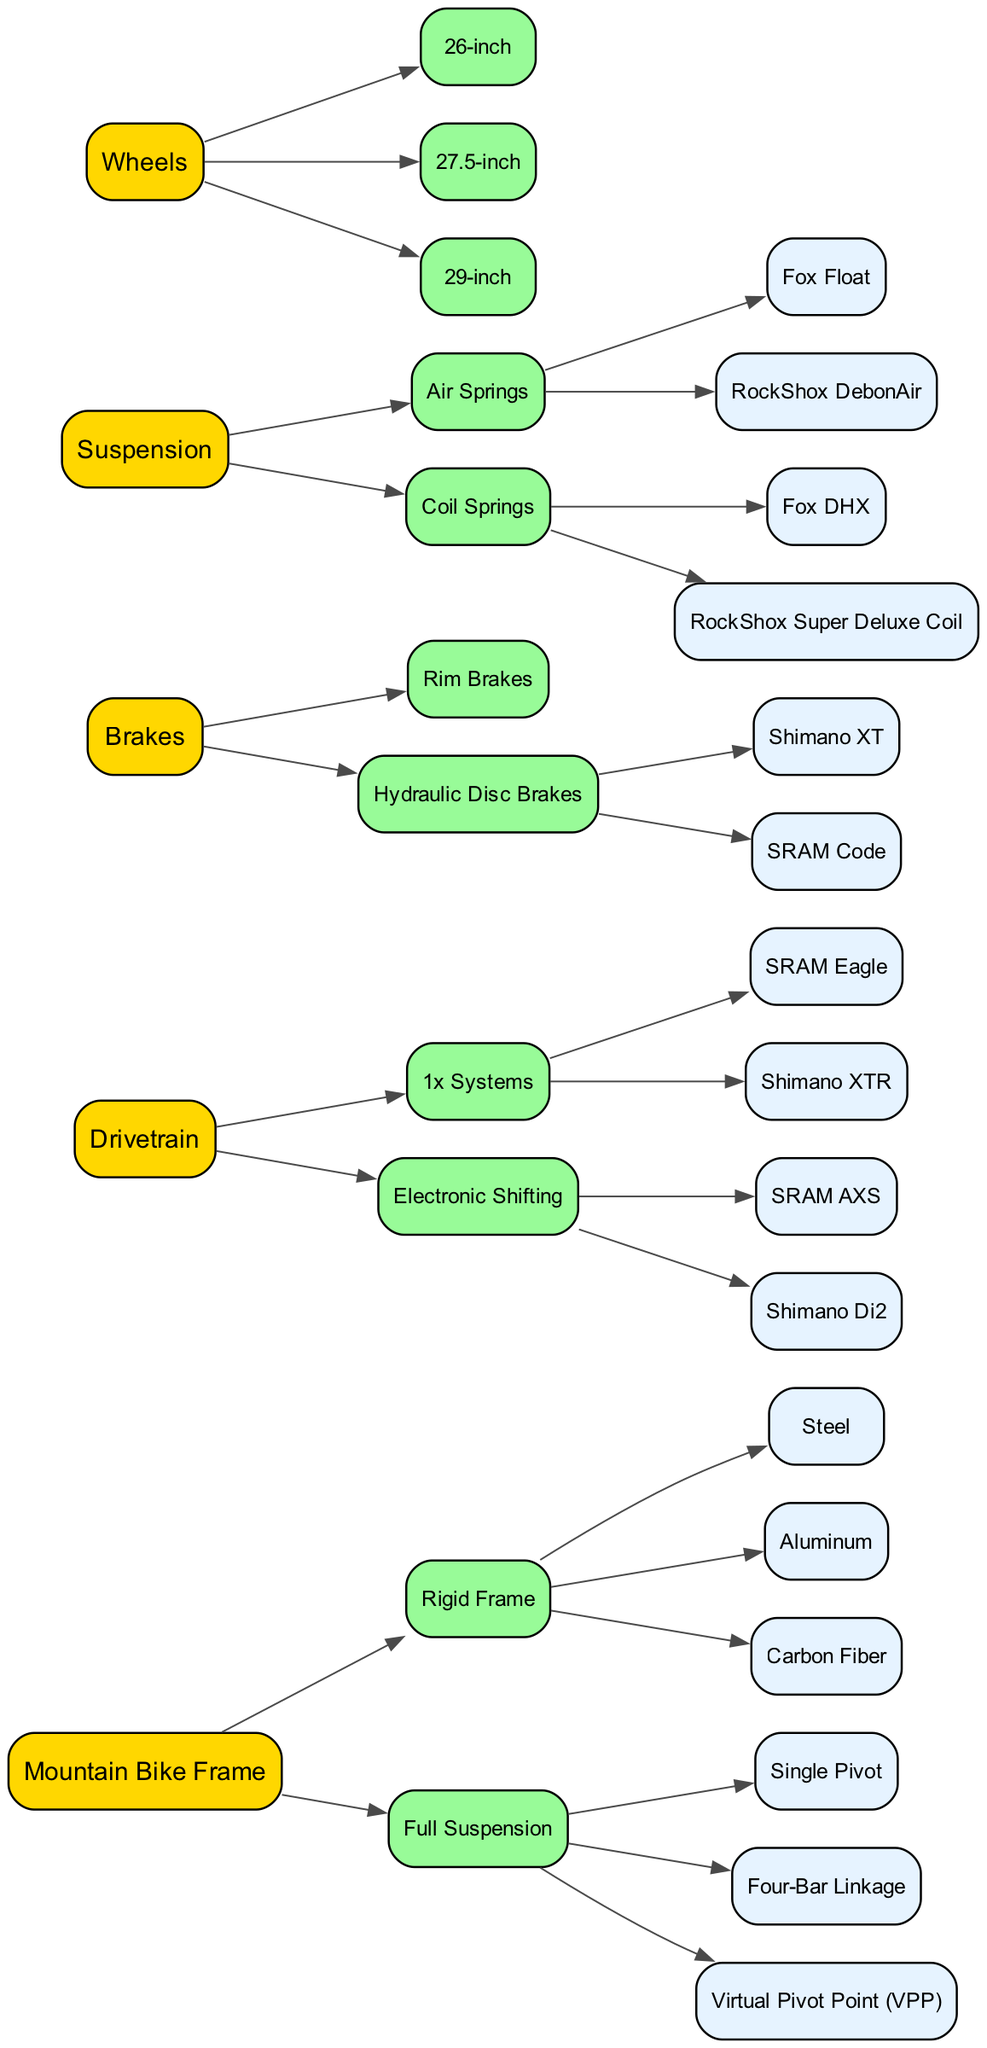What are the two main types of bike frames shown in the diagram? The diagram distinguishes between "Rigid Frame" and "Full Suspension" as the two primary categories of mountain bike frames.
Answer: Rigid Frame, Full Suspension How many types of suspension systems are illustrated in the tree? The tree outlines two main types of suspension systems: "Air Springs" and "Coil Springs." The total number is derived from counting these two categories.
Answer: 2 Which drivetrain system has electronic shifting available? The diagram lists two drivetrain systems under the "Electronic Shifting" category: "SRAM AXS" and "Shimano Di2." This indicates that both are equipped for electronic shifting.
Answer: SRAM AXS, Shimano Di2 What is the common material used in rigid frames? The "Rigid Frame" category has three materials listed: "Steel," "Aluminum," and "Carbon Fiber." Steel is one of the common materials used in rigid frames.
Answer: Steel Which brake type is associated with "Shimano XT" in the family tree? According to the diagram, "Shimano XT" falls under the category of "Hydraulic Disc Brakes," indicating this is the type of brake it is associated with.
Answer: Hydraulic Disc Brakes What is the maximum wheel size shown in the diagram? The diagram lists wheel sizes that include "26-inch," "27.5-inch," and "29-inch." The maximum of these listed sizes is "29-inch."
Answer: 29-inch Which type of suspension has a specific example of "Fox DHX" associated with it? The "Fox DHX" is specifically associated with the "Coil Springs" suspension type in the family tree. This indicates it is a type of coil spring suspension.
Answer: Coil Springs How many nodes are there under the "Brakes" category? Under the "Brakes" category, there are three nodes: "Rim Brakes" and "Hydraulic Disc Brakes," with "Shimano XT" and "SRAM Code" as examples under hydraulic disc brakes. Thus, the total count of nodes under "Brakes" is three.
Answer: 3 